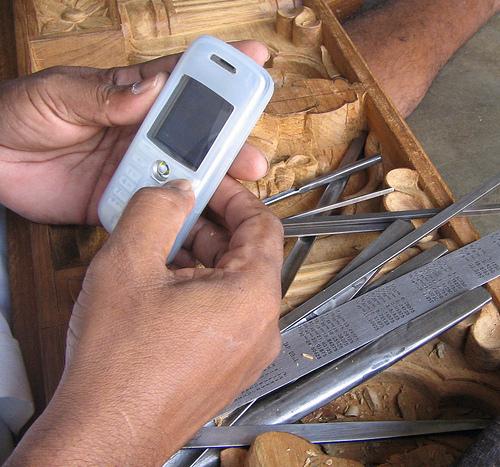What numbers are visible on the keypad?
Short answer required. 147. Is the person sitting on a chair?
Short answer required. No. What is this person's trade?
Keep it brief. Craftsman. 